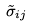<formula> <loc_0><loc_0><loc_500><loc_500>\tilde { \sigma } _ { i j }</formula> 